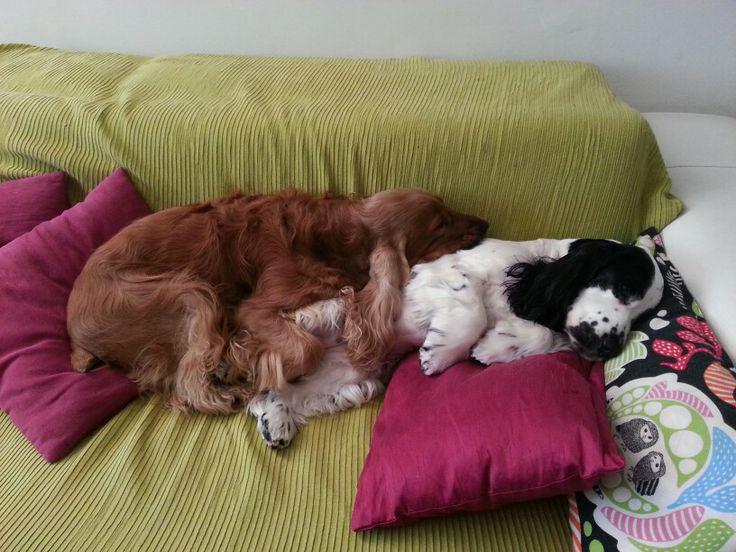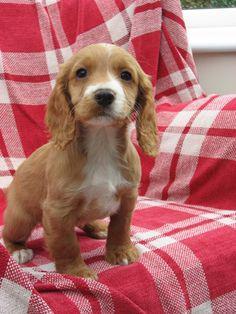The first image is the image on the left, the second image is the image on the right. Considering the images on both sides, is "There are only two dogs in total." valid? Answer yes or no. No. The first image is the image on the left, the second image is the image on the right. Assess this claim about the two images: "Two spaniels are next to each other on a sofa in one image, and the other image shows one puppy in the foreground.". Correct or not? Answer yes or no. Yes. 